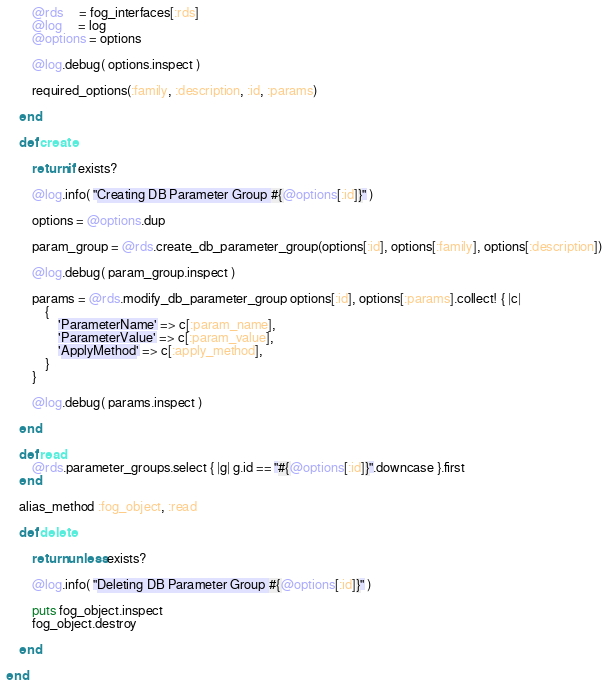Convert code to text. <code><loc_0><loc_0><loc_500><loc_500><_Ruby_>
        @rds     = fog_interfaces[:rds]
        @log     = log
        @options = options

        @log.debug( options.inspect )

        required_options(:family, :description, :id, :params)

    end

    def create
        
        return if exists?

        @log.info( "Creating DB Parameter Group #{@options[:id]}" )

        options = @options.dup

        param_group = @rds.create_db_parameter_group(options[:id], options[:family], options[:description])

        @log.debug( param_group.inspect )

        params = @rds.modify_db_parameter_group options[:id], options[:params].collect! { |c| 
            {
                'ParameterName' => c[:param_name],
                'ParameterValue' => c[:param_value],
                'ApplyMethod' => c[:apply_method],
            }
        }

        @log.debug( params.inspect )

    end

    def read
        @rds.parameter_groups.select { |g| g.id == "#{@options[:id]}".downcase }.first
    end

    alias_method :fog_object, :read

    def delete

        return unless exists?

        @log.info( "Deleting DB Parameter Group #{@options[:id]}" )

        puts fog_object.inspect
        fog_object.destroy

    end

end

</code> 